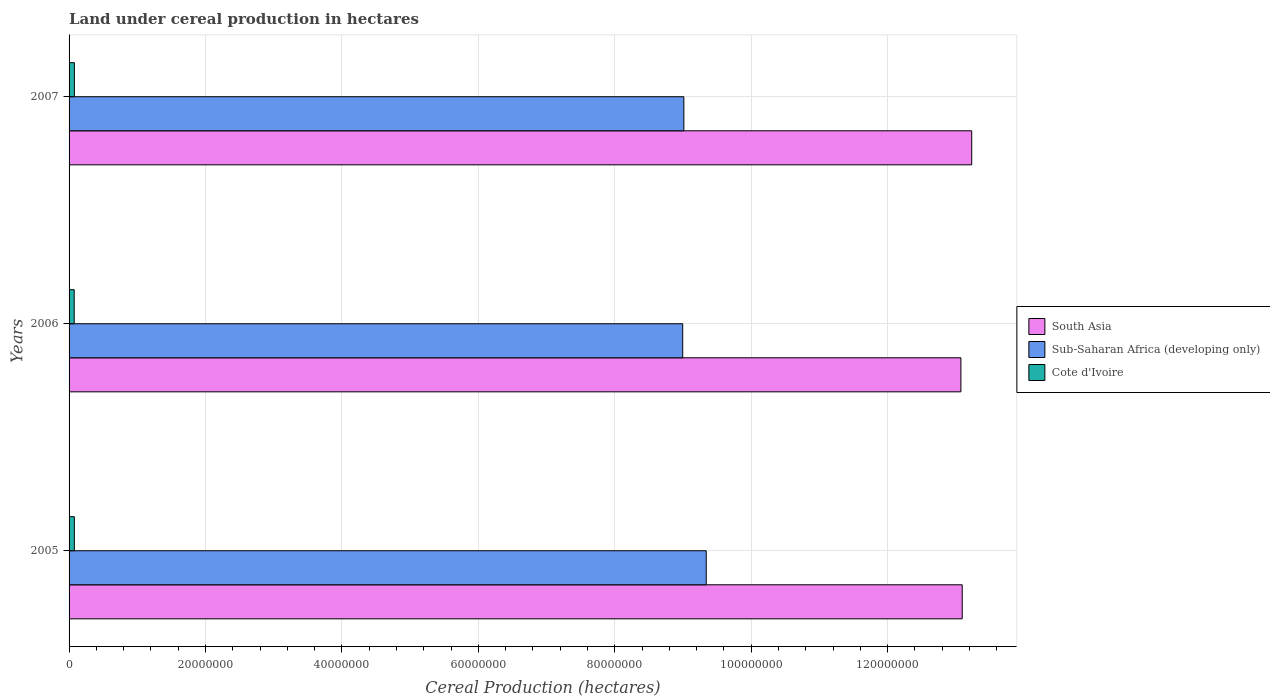How many different coloured bars are there?
Give a very brief answer. 3. Are the number of bars per tick equal to the number of legend labels?
Keep it short and to the point. Yes. Are the number of bars on each tick of the Y-axis equal?
Offer a terse response. Yes. How many bars are there on the 2nd tick from the bottom?
Your response must be concise. 3. In how many cases, is the number of bars for a given year not equal to the number of legend labels?
Offer a very short reply. 0. What is the land under cereal production in Cote d'Ivoire in 2007?
Give a very brief answer. 7.80e+05. Across all years, what is the maximum land under cereal production in Cote d'Ivoire?
Your answer should be compact. 7.80e+05. Across all years, what is the minimum land under cereal production in Cote d'Ivoire?
Keep it short and to the point. 7.52e+05. What is the total land under cereal production in Sub-Saharan Africa (developing only) in the graph?
Offer a very short reply. 2.73e+08. What is the difference between the land under cereal production in South Asia in 2005 and that in 2007?
Keep it short and to the point. -1.39e+06. What is the difference between the land under cereal production in Cote d'Ivoire in 2005 and the land under cereal production in South Asia in 2007?
Ensure brevity in your answer.  -1.32e+08. What is the average land under cereal production in South Asia per year?
Your answer should be compact. 1.31e+08. In the year 2006, what is the difference between the land under cereal production in South Asia and land under cereal production in Cote d'Ivoire?
Keep it short and to the point. 1.30e+08. What is the ratio of the land under cereal production in Cote d'Ivoire in 2005 to that in 2006?
Provide a short and direct response. 1.03. Is the difference between the land under cereal production in South Asia in 2005 and 2007 greater than the difference between the land under cereal production in Cote d'Ivoire in 2005 and 2007?
Provide a succinct answer. No. What is the difference between the highest and the second highest land under cereal production in Sub-Saharan Africa (developing only)?
Offer a very short reply. 3.28e+06. What is the difference between the highest and the lowest land under cereal production in Sub-Saharan Africa (developing only)?
Your answer should be compact. 3.45e+06. What does the 2nd bar from the top in 2005 represents?
Your answer should be very brief. Sub-Saharan Africa (developing only). What does the 3rd bar from the bottom in 2007 represents?
Your answer should be very brief. Cote d'Ivoire. Is it the case that in every year, the sum of the land under cereal production in Cote d'Ivoire and land under cereal production in South Asia is greater than the land under cereal production in Sub-Saharan Africa (developing only)?
Make the answer very short. Yes. What is the difference between two consecutive major ticks on the X-axis?
Provide a short and direct response. 2.00e+07. Does the graph contain any zero values?
Ensure brevity in your answer.  No. Does the graph contain grids?
Provide a short and direct response. Yes. Where does the legend appear in the graph?
Make the answer very short. Center right. How many legend labels are there?
Ensure brevity in your answer.  3. How are the legend labels stacked?
Offer a terse response. Vertical. What is the title of the graph?
Offer a very short reply. Land under cereal production in hectares. Does "New Caledonia" appear as one of the legend labels in the graph?
Ensure brevity in your answer.  No. What is the label or title of the X-axis?
Make the answer very short. Cereal Production (hectares). What is the label or title of the Y-axis?
Your response must be concise. Years. What is the Cereal Production (hectares) in South Asia in 2005?
Your answer should be compact. 1.31e+08. What is the Cereal Production (hectares) of Sub-Saharan Africa (developing only) in 2005?
Give a very brief answer. 9.34e+07. What is the Cereal Production (hectares) in Cote d'Ivoire in 2005?
Your answer should be compact. 7.76e+05. What is the Cereal Production (hectares) in South Asia in 2006?
Ensure brevity in your answer.  1.31e+08. What is the Cereal Production (hectares) of Sub-Saharan Africa (developing only) in 2006?
Offer a terse response. 9.00e+07. What is the Cereal Production (hectares) in Cote d'Ivoire in 2006?
Offer a very short reply. 7.52e+05. What is the Cereal Production (hectares) of South Asia in 2007?
Provide a short and direct response. 1.32e+08. What is the Cereal Production (hectares) in Sub-Saharan Africa (developing only) in 2007?
Your response must be concise. 9.01e+07. What is the Cereal Production (hectares) of Cote d'Ivoire in 2007?
Give a very brief answer. 7.80e+05. Across all years, what is the maximum Cereal Production (hectares) of South Asia?
Make the answer very short. 1.32e+08. Across all years, what is the maximum Cereal Production (hectares) in Sub-Saharan Africa (developing only)?
Provide a succinct answer. 9.34e+07. Across all years, what is the maximum Cereal Production (hectares) in Cote d'Ivoire?
Provide a short and direct response. 7.80e+05. Across all years, what is the minimum Cereal Production (hectares) of South Asia?
Offer a very short reply. 1.31e+08. Across all years, what is the minimum Cereal Production (hectares) of Sub-Saharan Africa (developing only)?
Provide a succinct answer. 9.00e+07. Across all years, what is the minimum Cereal Production (hectares) of Cote d'Ivoire?
Make the answer very short. 7.52e+05. What is the total Cereal Production (hectares) of South Asia in the graph?
Keep it short and to the point. 3.94e+08. What is the total Cereal Production (hectares) in Sub-Saharan Africa (developing only) in the graph?
Your response must be concise. 2.73e+08. What is the total Cereal Production (hectares) of Cote d'Ivoire in the graph?
Your answer should be compact. 2.31e+06. What is the difference between the Cereal Production (hectares) of South Asia in 2005 and that in 2006?
Make the answer very short. 1.92e+05. What is the difference between the Cereal Production (hectares) in Sub-Saharan Africa (developing only) in 2005 and that in 2006?
Offer a very short reply. 3.45e+06. What is the difference between the Cereal Production (hectares) in Cote d'Ivoire in 2005 and that in 2006?
Your response must be concise. 2.41e+04. What is the difference between the Cereal Production (hectares) in South Asia in 2005 and that in 2007?
Offer a terse response. -1.39e+06. What is the difference between the Cereal Production (hectares) of Sub-Saharan Africa (developing only) in 2005 and that in 2007?
Your response must be concise. 3.28e+06. What is the difference between the Cereal Production (hectares) in Cote d'Ivoire in 2005 and that in 2007?
Provide a succinct answer. -4308. What is the difference between the Cereal Production (hectares) in South Asia in 2006 and that in 2007?
Your response must be concise. -1.59e+06. What is the difference between the Cereal Production (hectares) in Sub-Saharan Africa (developing only) in 2006 and that in 2007?
Make the answer very short. -1.70e+05. What is the difference between the Cereal Production (hectares) in Cote d'Ivoire in 2006 and that in 2007?
Offer a very short reply. -2.84e+04. What is the difference between the Cereal Production (hectares) in South Asia in 2005 and the Cereal Production (hectares) in Sub-Saharan Africa (developing only) in 2006?
Your answer should be very brief. 4.10e+07. What is the difference between the Cereal Production (hectares) in South Asia in 2005 and the Cereal Production (hectares) in Cote d'Ivoire in 2006?
Keep it short and to the point. 1.30e+08. What is the difference between the Cereal Production (hectares) in Sub-Saharan Africa (developing only) in 2005 and the Cereal Production (hectares) in Cote d'Ivoire in 2006?
Your answer should be very brief. 9.27e+07. What is the difference between the Cereal Production (hectares) of South Asia in 2005 and the Cereal Production (hectares) of Sub-Saharan Africa (developing only) in 2007?
Provide a succinct answer. 4.08e+07. What is the difference between the Cereal Production (hectares) of South Asia in 2005 and the Cereal Production (hectares) of Cote d'Ivoire in 2007?
Offer a terse response. 1.30e+08. What is the difference between the Cereal Production (hectares) of Sub-Saharan Africa (developing only) in 2005 and the Cereal Production (hectares) of Cote d'Ivoire in 2007?
Your answer should be very brief. 9.26e+07. What is the difference between the Cereal Production (hectares) of South Asia in 2006 and the Cereal Production (hectares) of Sub-Saharan Africa (developing only) in 2007?
Your answer should be compact. 4.06e+07. What is the difference between the Cereal Production (hectares) of South Asia in 2006 and the Cereal Production (hectares) of Cote d'Ivoire in 2007?
Offer a terse response. 1.30e+08. What is the difference between the Cereal Production (hectares) in Sub-Saharan Africa (developing only) in 2006 and the Cereal Production (hectares) in Cote d'Ivoire in 2007?
Offer a terse response. 8.92e+07. What is the average Cereal Production (hectares) of South Asia per year?
Offer a terse response. 1.31e+08. What is the average Cereal Production (hectares) in Sub-Saharan Africa (developing only) per year?
Make the answer very short. 9.12e+07. What is the average Cereal Production (hectares) in Cote d'Ivoire per year?
Keep it short and to the point. 7.69e+05. In the year 2005, what is the difference between the Cereal Production (hectares) in South Asia and Cereal Production (hectares) in Sub-Saharan Africa (developing only)?
Your response must be concise. 3.75e+07. In the year 2005, what is the difference between the Cereal Production (hectares) in South Asia and Cereal Production (hectares) in Cote d'Ivoire?
Offer a very short reply. 1.30e+08. In the year 2005, what is the difference between the Cereal Production (hectares) in Sub-Saharan Africa (developing only) and Cereal Production (hectares) in Cote d'Ivoire?
Offer a terse response. 9.26e+07. In the year 2006, what is the difference between the Cereal Production (hectares) in South Asia and Cereal Production (hectares) in Sub-Saharan Africa (developing only)?
Your response must be concise. 4.08e+07. In the year 2006, what is the difference between the Cereal Production (hectares) of South Asia and Cereal Production (hectares) of Cote d'Ivoire?
Your response must be concise. 1.30e+08. In the year 2006, what is the difference between the Cereal Production (hectares) in Sub-Saharan Africa (developing only) and Cereal Production (hectares) in Cote d'Ivoire?
Your answer should be compact. 8.92e+07. In the year 2007, what is the difference between the Cereal Production (hectares) of South Asia and Cereal Production (hectares) of Sub-Saharan Africa (developing only)?
Ensure brevity in your answer.  4.22e+07. In the year 2007, what is the difference between the Cereal Production (hectares) of South Asia and Cereal Production (hectares) of Cote d'Ivoire?
Ensure brevity in your answer.  1.32e+08. In the year 2007, what is the difference between the Cereal Production (hectares) in Sub-Saharan Africa (developing only) and Cereal Production (hectares) in Cote d'Ivoire?
Provide a succinct answer. 8.93e+07. What is the ratio of the Cereal Production (hectares) of Sub-Saharan Africa (developing only) in 2005 to that in 2006?
Your answer should be compact. 1.04. What is the ratio of the Cereal Production (hectares) in Cote d'Ivoire in 2005 to that in 2006?
Make the answer very short. 1.03. What is the ratio of the Cereal Production (hectares) in South Asia in 2005 to that in 2007?
Your answer should be very brief. 0.99. What is the ratio of the Cereal Production (hectares) of Sub-Saharan Africa (developing only) in 2005 to that in 2007?
Your response must be concise. 1.04. What is the ratio of the Cereal Production (hectares) in South Asia in 2006 to that in 2007?
Keep it short and to the point. 0.99. What is the ratio of the Cereal Production (hectares) of Cote d'Ivoire in 2006 to that in 2007?
Offer a terse response. 0.96. What is the difference between the highest and the second highest Cereal Production (hectares) in South Asia?
Make the answer very short. 1.39e+06. What is the difference between the highest and the second highest Cereal Production (hectares) of Sub-Saharan Africa (developing only)?
Offer a very short reply. 3.28e+06. What is the difference between the highest and the second highest Cereal Production (hectares) of Cote d'Ivoire?
Provide a succinct answer. 4308. What is the difference between the highest and the lowest Cereal Production (hectares) of South Asia?
Make the answer very short. 1.59e+06. What is the difference between the highest and the lowest Cereal Production (hectares) of Sub-Saharan Africa (developing only)?
Provide a short and direct response. 3.45e+06. What is the difference between the highest and the lowest Cereal Production (hectares) in Cote d'Ivoire?
Offer a very short reply. 2.84e+04. 